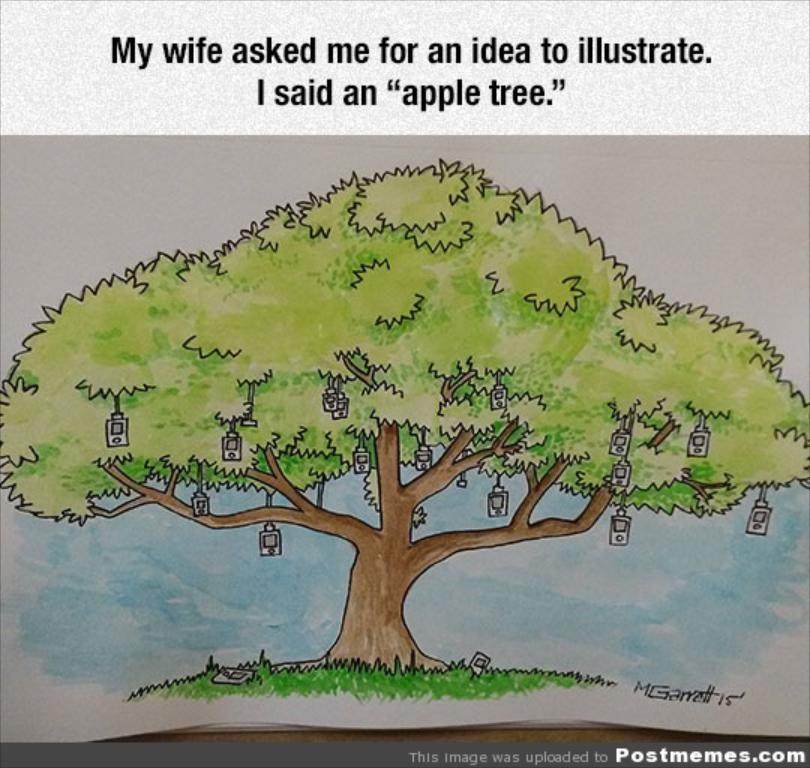What type of visual is the image? The image is a poster. Where is text located on the poster? There is text on the top and bottom of the poster. What can be seen on the tree in the image? There are objects visible on a tree in the image. What can be seen on the grass in the image? There are objects visible on the grass in the image. How many buns are being held by the sisters in the image? There are no sisters or buns present in the image. What type of crack is visible on the tree in the image? There is no crack visible on the tree in the image. 